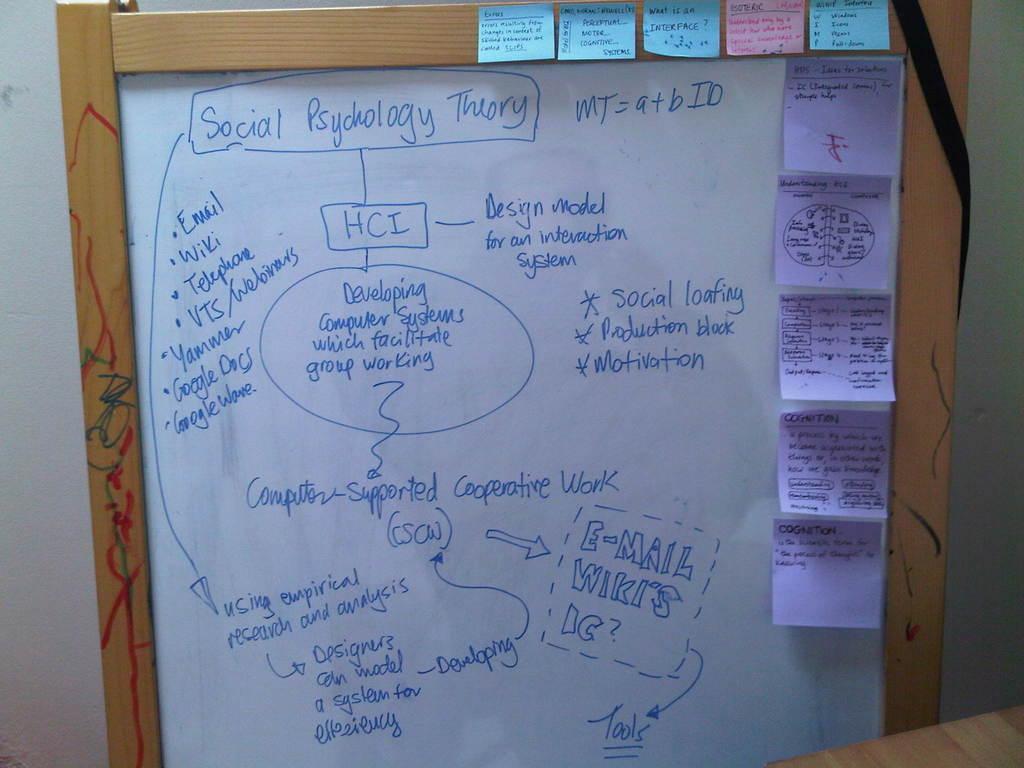What is mt equal to?
Offer a terse response. A+bid. What is hci?
Your answer should be very brief. Design model for an interaction system. 